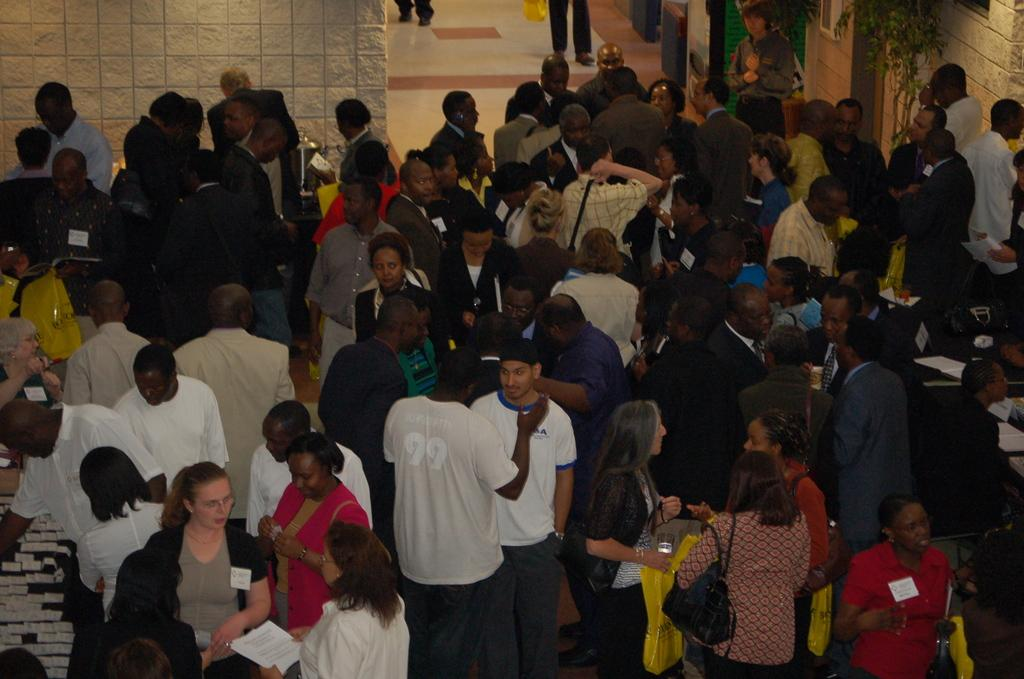How many people are in the image? There is a group of people in the image. What are the people doing in the image? The people are standing on the floor. What are the people holding in their hands? The people are holding objects in their hands. What can be seen in the background of the image? There is a wall and other objects visible in the background of the image. What type of loaf is being served at the birthday celebration in the image? There is no loaf or birthday celebration present in the image. What type of guitar is being played by the person in the image? There is no guitar or person playing a guitar present in the image. 